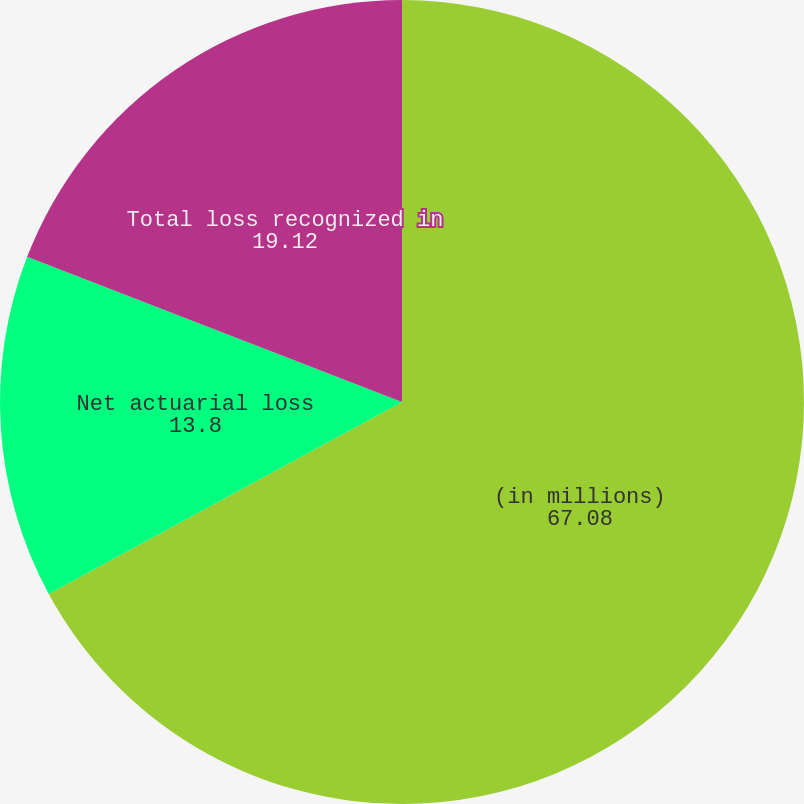<chart> <loc_0><loc_0><loc_500><loc_500><pie_chart><fcel>(in millions)<fcel>Net actuarial loss<fcel>Total loss recognized in<nl><fcel>67.08%<fcel>13.8%<fcel>19.12%<nl></chart> 